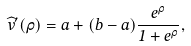<formula> <loc_0><loc_0><loc_500><loc_500>\widehat { v } ^ { \prime } ( \rho ) = a + ( b - a ) \frac { e ^ { \rho } } { 1 + e ^ { \rho } } ,</formula> 